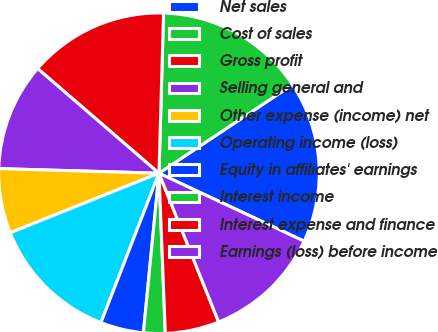<chart> <loc_0><loc_0><loc_500><loc_500><pie_chart><fcel>Net sales<fcel>Cost of sales<fcel>Gross profit<fcel>Selling general and<fcel>Other expense (income) net<fcel>Operating income (loss)<fcel>Equity in affiliates' earnings<fcel>Interest income<fcel>Interest expense and finance<fcel>Earnings (loss) before income<nl><fcel>16.3%<fcel>15.22%<fcel>14.13%<fcel>10.87%<fcel>6.52%<fcel>13.04%<fcel>4.35%<fcel>2.18%<fcel>5.44%<fcel>11.96%<nl></chart> 